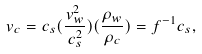Convert formula to latex. <formula><loc_0><loc_0><loc_500><loc_500>v _ { c } = c _ { s } ( \frac { v _ { w } ^ { 2 } } { c _ { s } ^ { 2 } } ) ( \frac { \rho _ { w } } { \rho _ { c } } ) = f ^ { - 1 } c _ { s } ,</formula> 